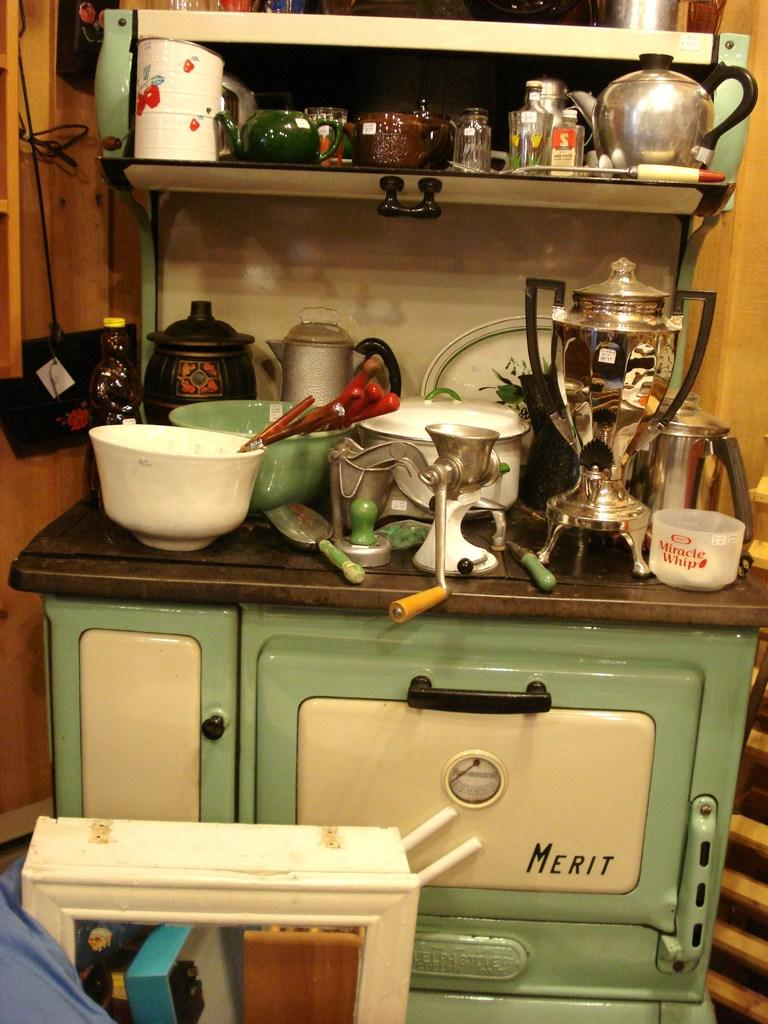<image>
Write a terse but informative summary of the picture. A cluttered kitchen counter top sitting on top of a drawer with the word Merit on it. 